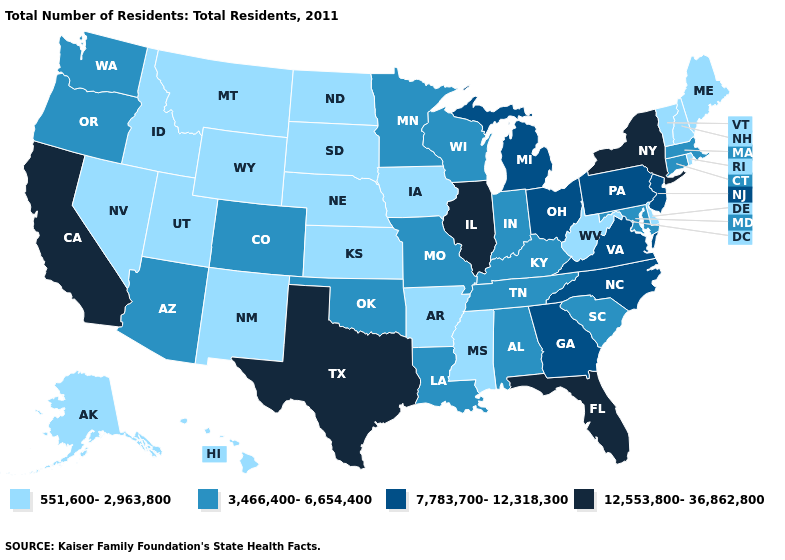Among the states that border Oklahoma , which have the lowest value?
Concise answer only. Arkansas, Kansas, New Mexico. What is the value of Arkansas?
Keep it brief. 551,600-2,963,800. Among the states that border New Mexico , does Utah have the highest value?
Concise answer only. No. Does North Carolina have the same value as Louisiana?
Write a very short answer. No. Name the states that have a value in the range 551,600-2,963,800?
Keep it brief. Alaska, Arkansas, Delaware, Hawaii, Idaho, Iowa, Kansas, Maine, Mississippi, Montana, Nebraska, Nevada, New Hampshire, New Mexico, North Dakota, Rhode Island, South Dakota, Utah, Vermont, West Virginia, Wyoming. What is the value of Delaware?
Concise answer only. 551,600-2,963,800. Which states have the highest value in the USA?
Quick response, please. California, Florida, Illinois, New York, Texas. Which states have the lowest value in the South?
Quick response, please. Arkansas, Delaware, Mississippi, West Virginia. What is the lowest value in states that border Tennessee?
Quick response, please. 551,600-2,963,800. Does Florida have the highest value in the South?
Concise answer only. Yes. Among the states that border Georgia , which have the highest value?
Concise answer only. Florida. Name the states that have a value in the range 12,553,800-36,862,800?
Quick response, please. California, Florida, Illinois, New York, Texas. What is the lowest value in the Northeast?
Give a very brief answer. 551,600-2,963,800. Name the states that have a value in the range 551,600-2,963,800?
Give a very brief answer. Alaska, Arkansas, Delaware, Hawaii, Idaho, Iowa, Kansas, Maine, Mississippi, Montana, Nebraska, Nevada, New Hampshire, New Mexico, North Dakota, Rhode Island, South Dakota, Utah, Vermont, West Virginia, Wyoming. Does Pennsylvania have the same value as Georgia?
Short answer required. Yes. 